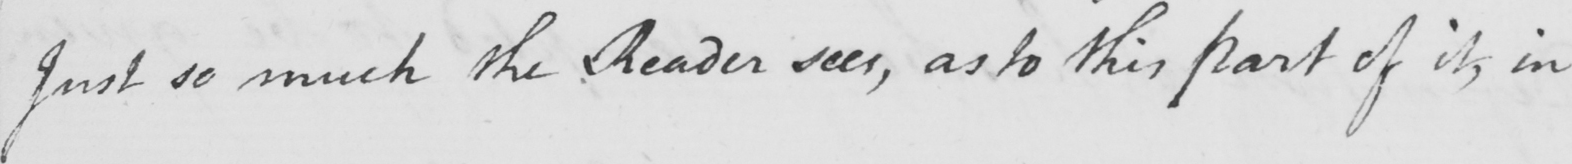Transcribe the text shown in this historical manuscript line. Just so much the Reader sees , as to this part of it , in 